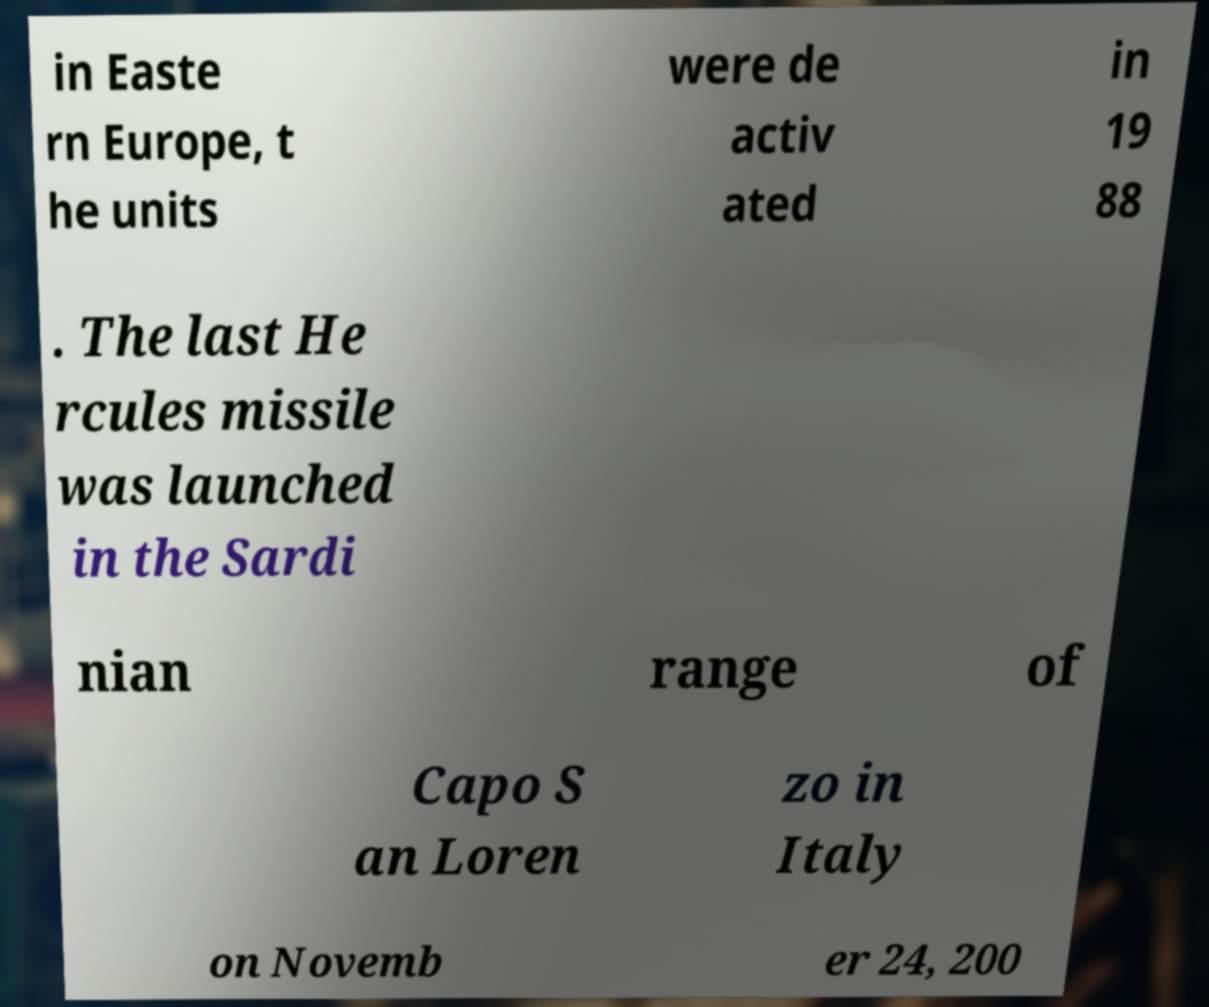I need the written content from this picture converted into text. Can you do that? in Easte rn Europe, t he units were de activ ated in 19 88 . The last He rcules missile was launched in the Sardi nian range of Capo S an Loren zo in Italy on Novemb er 24, 200 